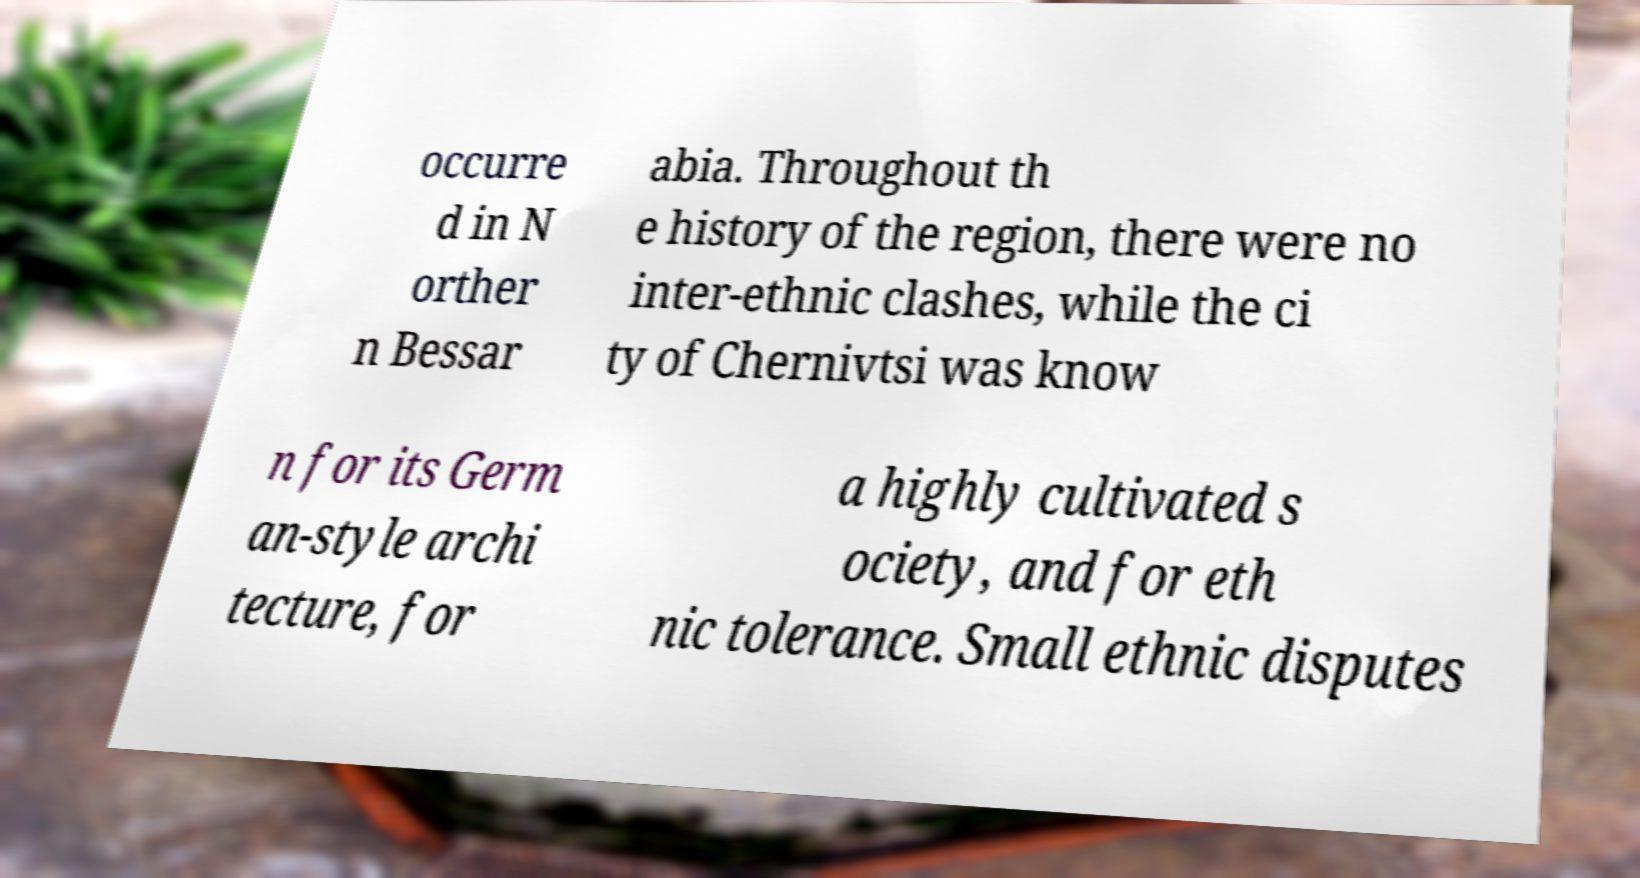Please identify and transcribe the text found in this image. occurre d in N orther n Bessar abia. Throughout th e history of the region, there were no inter-ethnic clashes, while the ci ty of Chernivtsi was know n for its Germ an-style archi tecture, for a highly cultivated s ociety, and for eth nic tolerance. Small ethnic disputes 